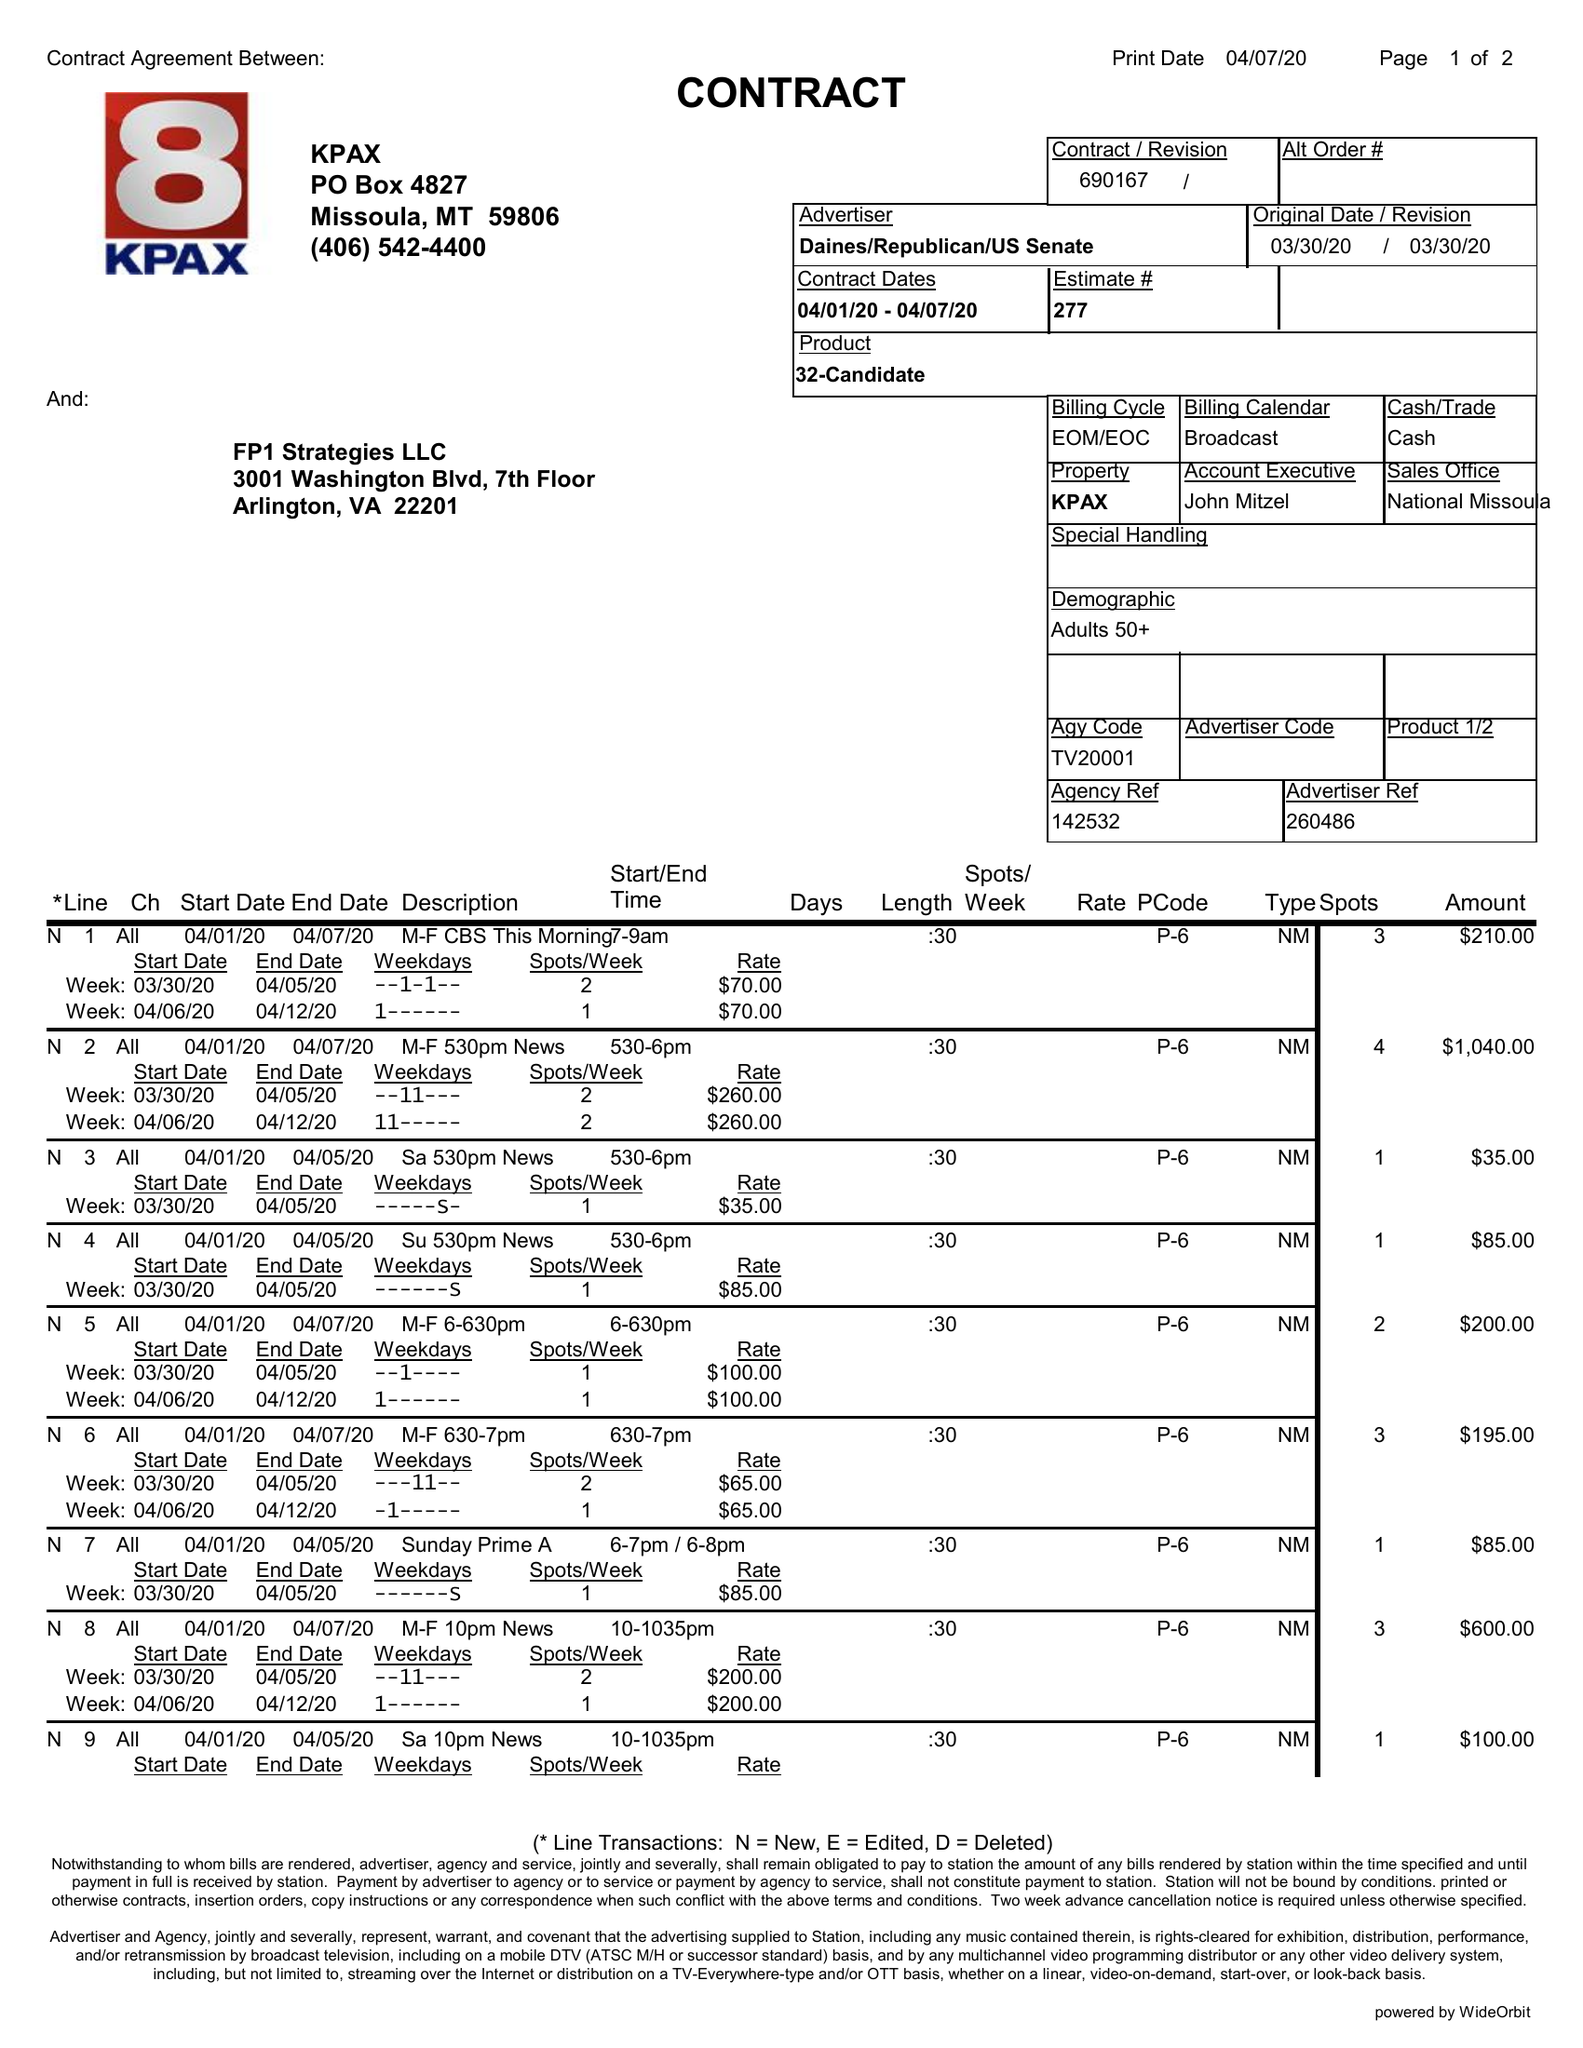What is the value for the flight_from?
Answer the question using a single word or phrase. 04/01/20 